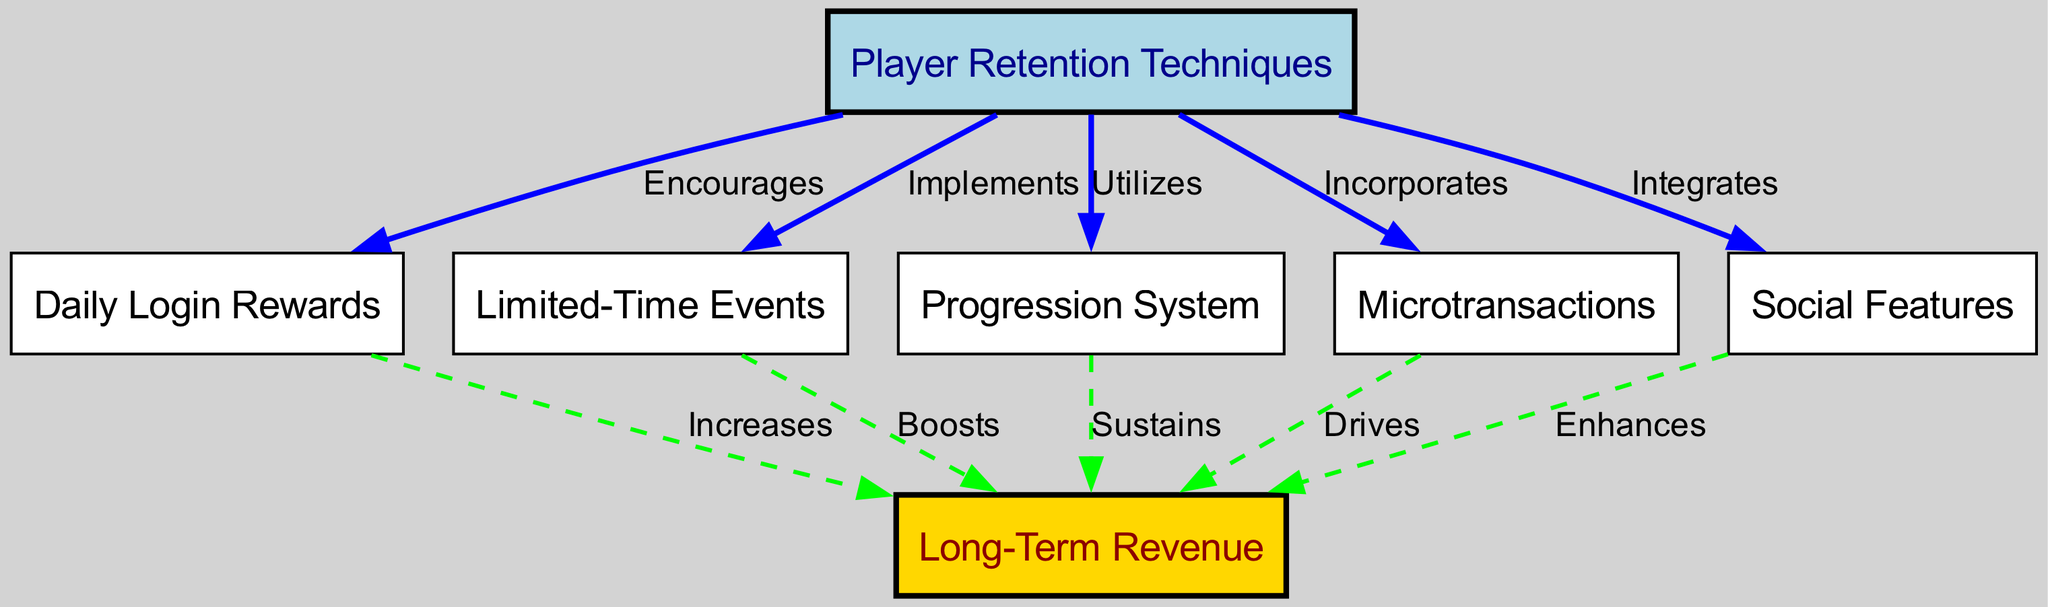What are the player retention techniques mentioned in the diagram? The diagram lists five player retention techniques: Daily Login Rewards, Limited-Time Events, Progression System, Microtransactions, and Social Features.
Answer: Daily Login Rewards, Limited-Time Events, Progression System, Microtransactions, Social Features How many nodes are in the diagram? The diagram contains six nodes: Player Retention Techniques, Daily Login Rewards, Limited-Time Events, Progression System, Microtransactions, Social Features, and Long-Term Revenue.
Answer: Six What relationship does 'Daily Login Rewards' have with 'Revenue'? The edge between 'Daily Login Rewards' and 'Revenue' shows that Daily Login Rewards increases Revenue.
Answer: Increases Which player retention technique incorporates microtransactions? The diagram directly connects 'Player Retention Techniques' to 'Microtransactions' with the label 'Incorporates'.
Answer: Microtransactions What is the impact of the 'Progression System' on long-term revenue? The 'Progression System' sustains long-term revenue, as indicated by the edge from it to the 'Revenue' node.
Answer: Sustains Which technique integrates social features? 'Player Retention Techniques' integrates 'Social Features', as shown in the diagram by the edge connecting them with the label 'Integrates'.
Answer: Social Features What color represents the 'Revenue' node? The 'Revenue' node is represented in gold color, which distinguishes it from the other nodes.
Answer: Gold How many edges are there that lead to 'Revenue'? There are five edges leading to 'Revenue', each connecting different player retention techniques to the revenue node.
Answer: Five What does 'Limited-Time Events' do to long-term revenue? The edge between 'Limited-Time Events' and 'Revenue' indicates that it boosts long-term revenue.
Answer: Boosts 